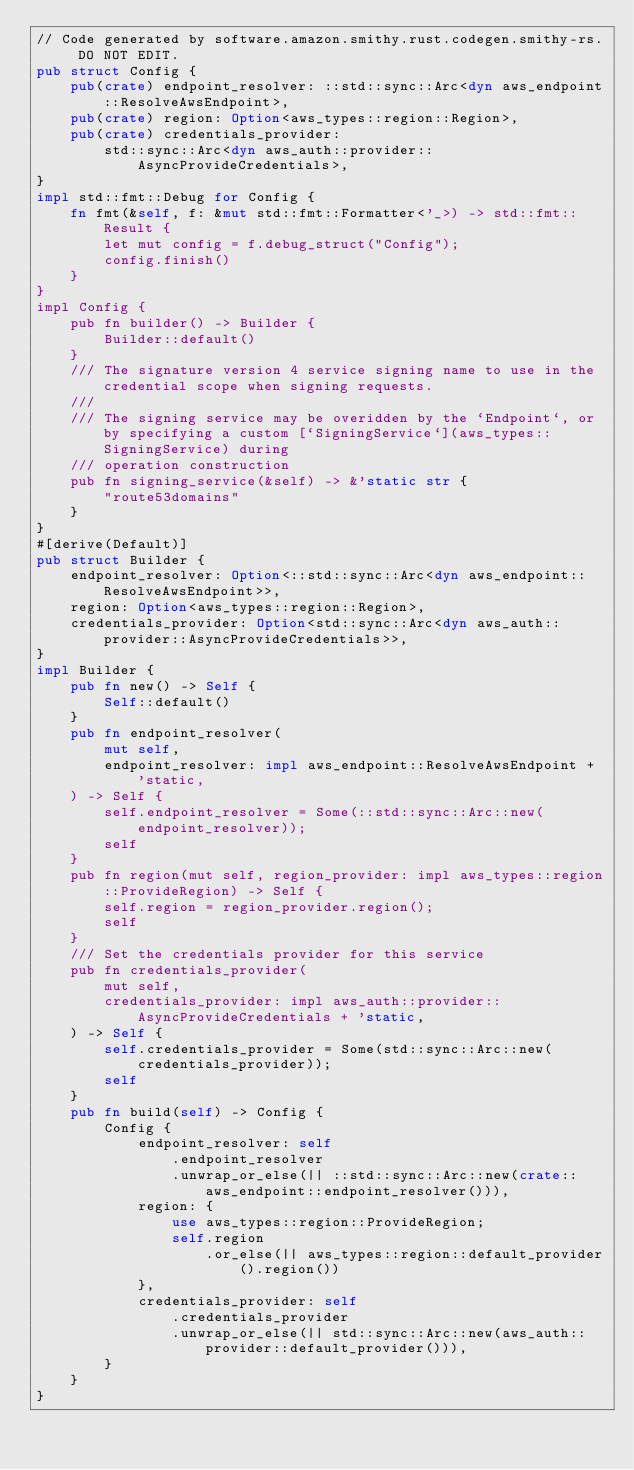Convert code to text. <code><loc_0><loc_0><loc_500><loc_500><_Rust_>// Code generated by software.amazon.smithy.rust.codegen.smithy-rs. DO NOT EDIT.
pub struct Config {
    pub(crate) endpoint_resolver: ::std::sync::Arc<dyn aws_endpoint::ResolveAwsEndpoint>,
    pub(crate) region: Option<aws_types::region::Region>,
    pub(crate) credentials_provider:
        std::sync::Arc<dyn aws_auth::provider::AsyncProvideCredentials>,
}
impl std::fmt::Debug for Config {
    fn fmt(&self, f: &mut std::fmt::Formatter<'_>) -> std::fmt::Result {
        let mut config = f.debug_struct("Config");
        config.finish()
    }
}
impl Config {
    pub fn builder() -> Builder {
        Builder::default()
    }
    /// The signature version 4 service signing name to use in the credential scope when signing requests.
    ///
    /// The signing service may be overidden by the `Endpoint`, or by specifying a custom [`SigningService`](aws_types::SigningService) during
    /// operation construction
    pub fn signing_service(&self) -> &'static str {
        "route53domains"
    }
}
#[derive(Default)]
pub struct Builder {
    endpoint_resolver: Option<::std::sync::Arc<dyn aws_endpoint::ResolveAwsEndpoint>>,
    region: Option<aws_types::region::Region>,
    credentials_provider: Option<std::sync::Arc<dyn aws_auth::provider::AsyncProvideCredentials>>,
}
impl Builder {
    pub fn new() -> Self {
        Self::default()
    }
    pub fn endpoint_resolver(
        mut self,
        endpoint_resolver: impl aws_endpoint::ResolveAwsEndpoint + 'static,
    ) -> Self {
        self.endpoint_resolver = Some(::std::sync::Arc::new(endpoint_resolver));
        self
    }
    pub fn region(mut self, region_provider: impl aws_types::region::ProvideRegion) -> Self {
        self.region = region_provider.region();
        self
    }
    /// Set the credentials provider for this service
    pub fn credentials_provider(
        mut self,
        credentials_provider: impl aws_auth::provider::AsyncProvideCredentials + 'static,
    ) -> Self {
        self.credentials_provider = Some(std::sync::Arc::new(credentials_provider));
        self
    }
    pub fn build(self) -> Config {
        Config {
            endpoint_resolver: self
                .endpoint_resolver
                .unwrap_or_else(|| ::std::sync::Arc::new(crate::aws_endpoint::endpoint_resolver())),
            region: {
                use aws_types::region::ProvideRegion;
                self.region
                    .or_else(|| aws_types::region::default_provider().region())
            },
            credentials_provider: self
                .credentials_provider
                .unwrap_or_else(|| std::sync::Arc::new(aws_auth::provider::default_provider())),
        }
    }
}
</code> 